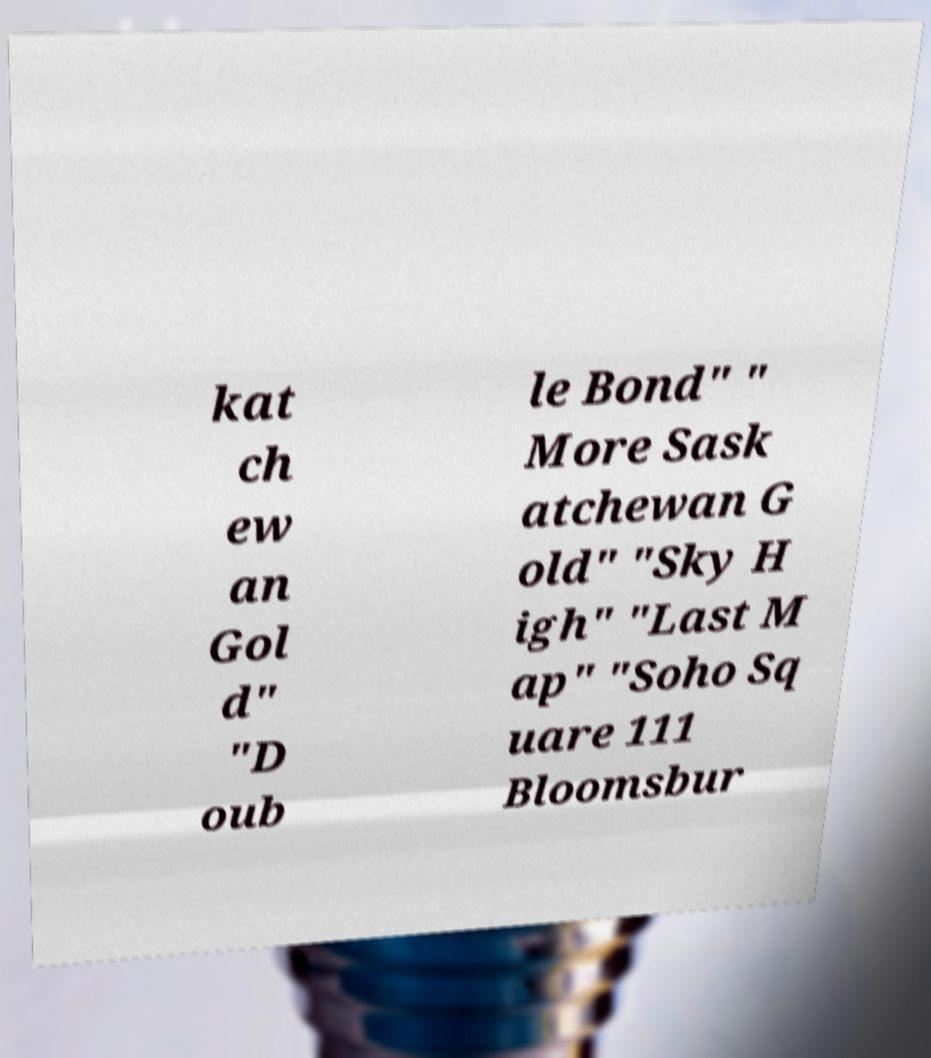There's text embedded in this image that I need extracted. Can you transcribe it verbatim? kat ch ew an Gol d" "D oub le Bond" " More Sask atchewan G old" "Sky H igh" "Last M ap" "Soho Sq uare 111 Bloomsbur 